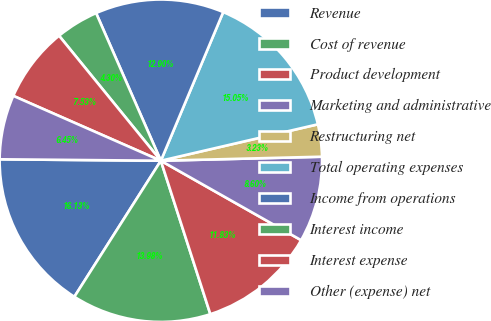<chart> <loc_0><loc_0><loc_500><loc_500><pie_chart><fcel>Revenue<fcel>Cost of revenue<fcel>Product development<fcel>Marketing and administrative<fcel>Restructuring net<fcel>Total operating expenses<fcel>Income from operations<fcel>Interest income<fcel>Interest expense<fcel>Other (expense) net<nl><fcel>16.13%<fcel>13.98%<fcel>11.83%<fcel>8.6%<fcel>3.23%<fcel>15.05%<fcel>12.9%<fcel>4.3%<fcel>7.53%<fcel>6.45%<nl></chart> 